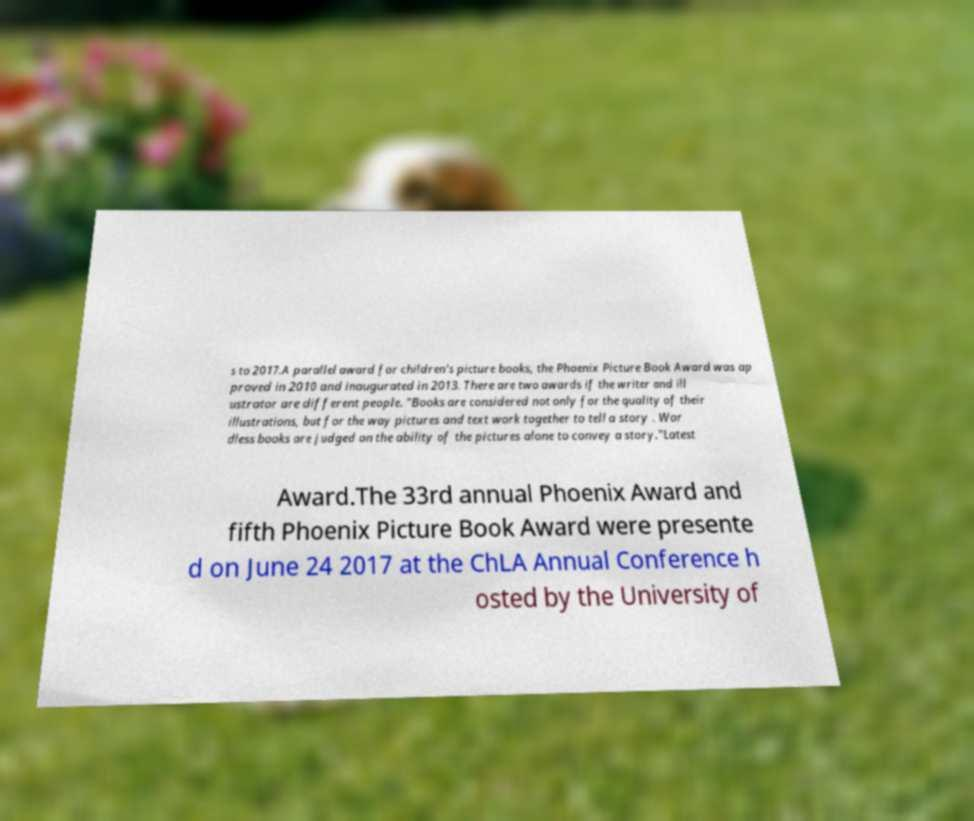Please identify and transcribe the text found in this image. s to 2017.A parallel award for children's picture books, the Phoenix Picture Book Award was ap proved in 2010 and inaugurated in 2013. There are two awards if the writer and ill ustrator are different people. "Books are considered not only for the quality of their illustrations, but for the way pictures and text work together to tell a story . Wor dless books are judged on the ability of the pictures alone to convey a story."Latest Award.The 33rd annual Phoenix Award and fifth Phoenix Picture Book Award were presente d on June 24 2017 at the ChLA Annual Conference h osted by the University of 